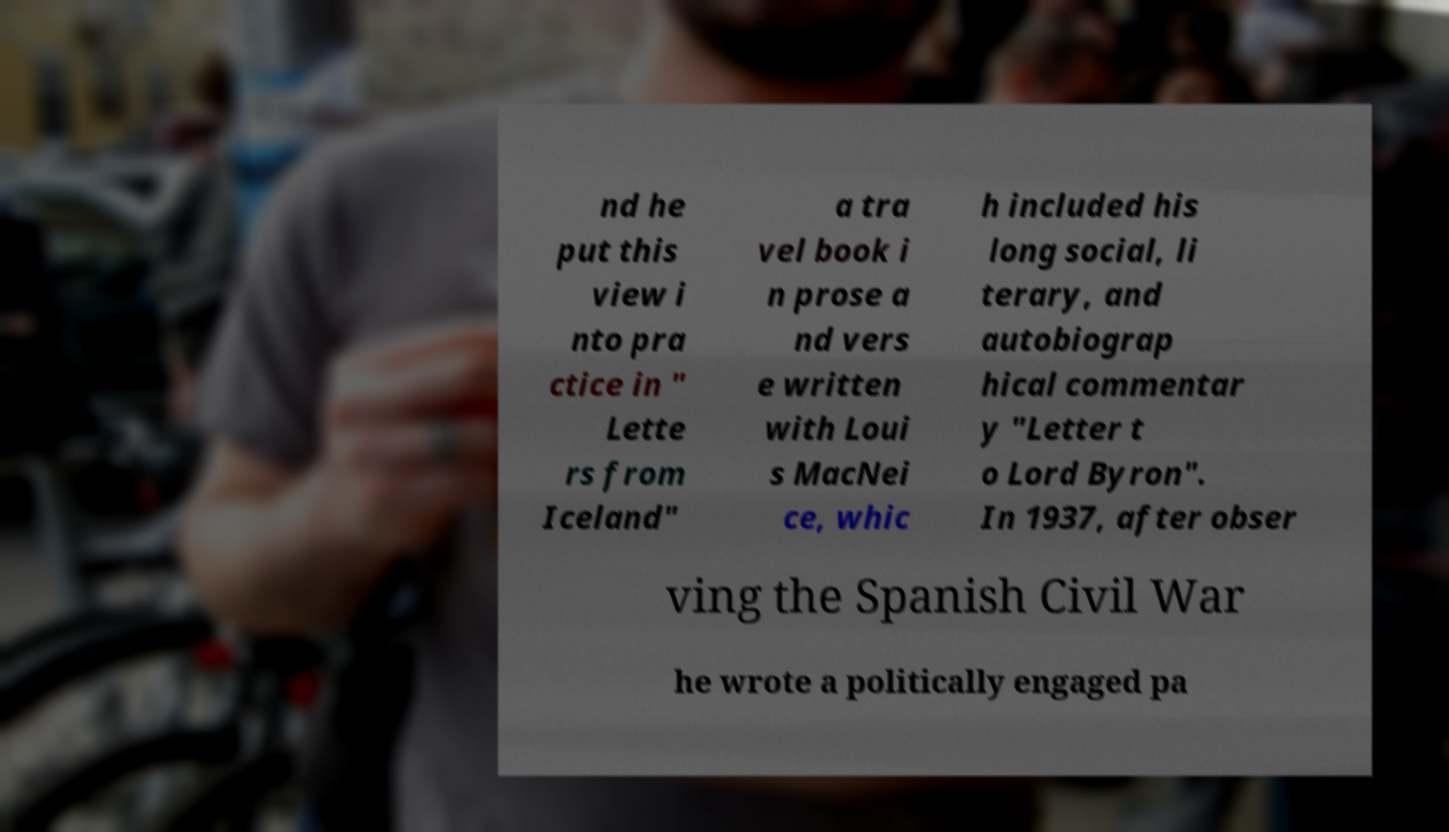Could you assist in decoding the text presented in this image and type it out clearly? nd he put this view i nto pra ctice in " Lette rs from Iceland" a tra vel book i n prose a nd vers e written with Loui s MacNei ce, whic h included his long social, li terary, and autobiograp hical commentar y "Letter t o Lord Byron". In 1937, after obser ving the Spanish Civil War he wrote a politically engaged pa 